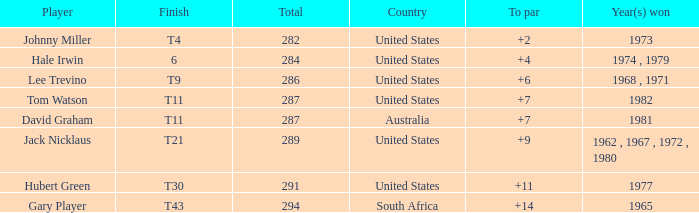WHAT IS THE TOTAL, OF A TO PAR FOR HUBERT GREEN, AND A TOTAL LARGER THAN 291? 0.0. 